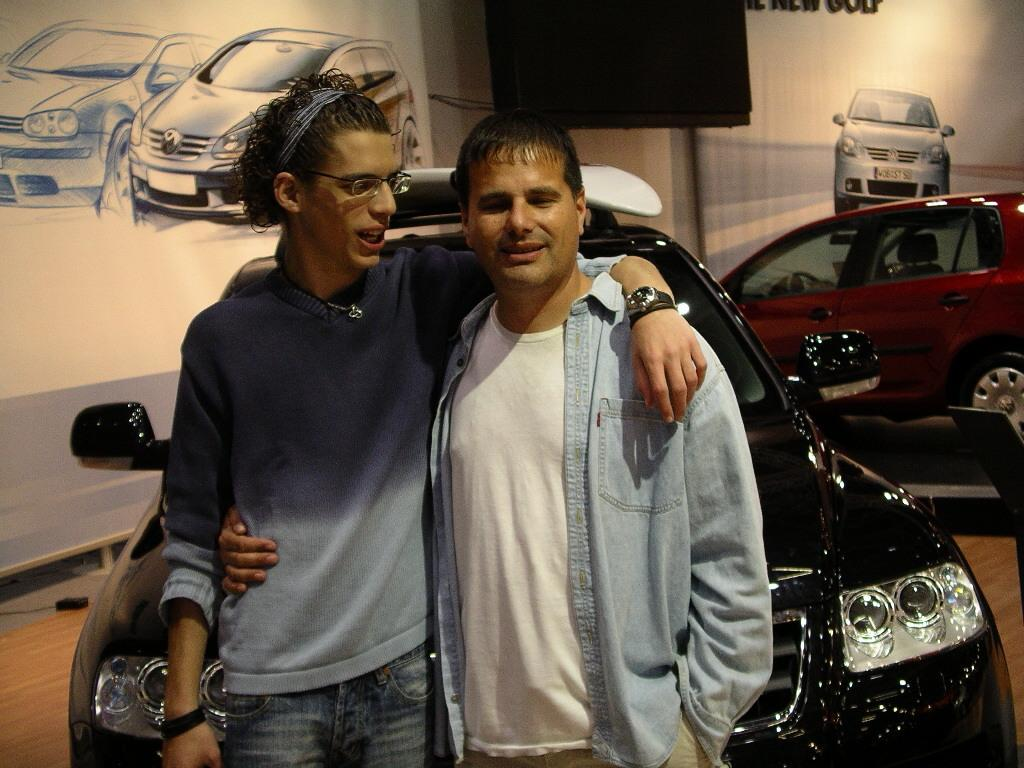How many people are in the image? There are two people in the image. What can be observed about the people's clothing? The people are wearing different color dresses. What can be seen to the right of the image? There are cars visible to the right of the image. What is present in the background of the image? There is a screen and boards in the background of the image. What type of texture can be seen on the hen in the image? There is no hen present in the image. How many cans are visible in the image? There is no can present in the image. 